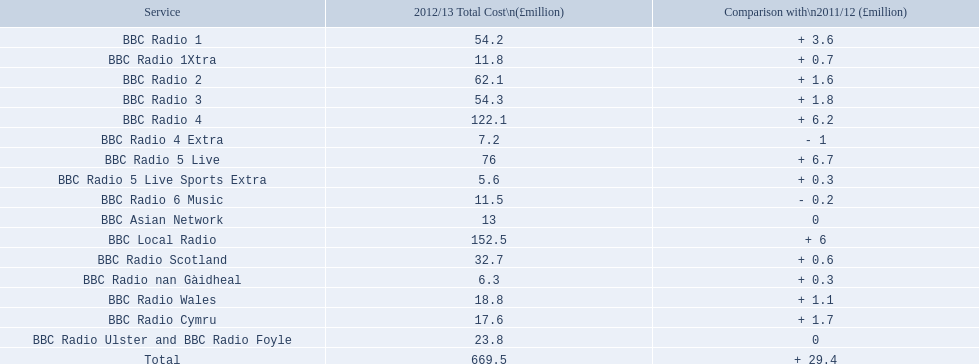Which services are there for bbc radio? BBC Radio 1, BBC Radio 1Xtra, BBC Radio 2, BBC Radio 3, BBC Radio 4, BBC Radio 4 Extra, BBC Radio 5 Live, BBC Radio 5 Live Sports Extra, BBC Radio 6 Music, BBC Asian Network, BBC Local Radio, BBC Radio Scotland, BBC Radio nan Gàidheal, BBC Radio Wales, BBC Radio Cymru, BBC Radio Ulster and BBC Radio Foyle. Of those which one had the highest cost? BBC Local Radio. 